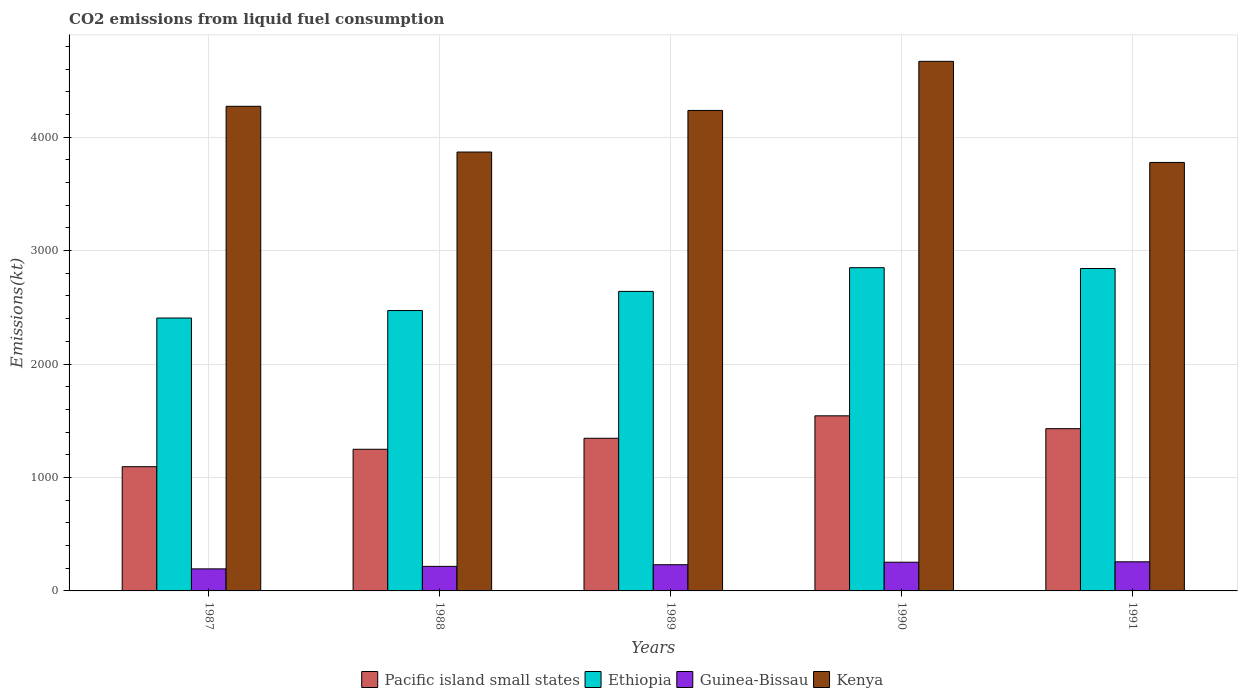How many different coloured bars are there?
Provide a succinct answer. 4. How many groups of bars are there?
Keep it short and to the point. 5. Are the number of bars per tick equal to the number of legend labels?
Make the answer very short. Yes. Are the number of bars on each tick of the X-axis equal?
Keep it short and to the point. Yes. What is the label of the 2nd group of bars from the left?
Keep it short and to the point. 1988. What is the amount of CO2 emitted in Guinea-Bissau in 1989?
Keep it short and to the point. 231.02. Across all years, what is the maximum amount of CO2 emitted in Kenya?
Your answer should be very brief. 4668.09. Across all years, what is the minimum amount of CO2 emitted in Ethiopia?
Give a very brief answer. 2405.55. What is the total amount of CO2 emitted in Kenya in the graph?
Offer a terse response. 2.08e+04. What is the difference between the amount of CO2 emitted in Ethiopia in 1988 and that in 1989?
Make the answer very short. -168.68. What is the difference between the amount of CO2 emitted in Guinea-Bissau in 1988 and the amount of CO2 emitted in Kenya in 1991?
Ensure brevity in your answer.  -3560.66. What is the average amount of CO2 emitted in Pacific island small states per year?
Give a very brief answer. 1332.55. In the year 1989, what is the difference between the amount of CO2 emitted in Ethiopia and amount of CO2 emitted in Guinea-Bissau?
Offer a terse response. 2409.22. In how many years, is the amount of CO2 emitted in Ethiopia greater than 600 kt?
Make the answer very short. 5. What is the ratio of the amount of CO2 emitted in Guinea-Bissau in 1988 to that in 1989?
Your response must be concise. 0.94. What is the difference between the highest and the second highest amount of CO2 emitted in Pacific island small states?
Make the answer very short. 113.32. What is the difference between the highest and the lowest amount of CO2 emitted in Pacific island small states?
Your answer should be compact. 448.51. In how many years, is the amount of CO2 emitted in Ethiopia greater than the average amount of CO2 emitted in Ethiopia taken over all years?
Offer a very short reply. 2. Is the sum of the amount of CO2 emitted in Guinea-Bissau in 1990 and 1991 greater than the maximum amount of CO2 emitted in Kenya across all years?
Give a very brief answer. No. What does the 1st bar from the left in 1989 represents?
Your response must be concise. Pacific island small states. What does the 4th bar from the right in 1990 represents?
Provide a short and direct response. Pacific island small states. Are the values on the major ticks of Y-axis written in scientific E-notation?
Ensure brevity in your answer.  No. Does the graph contain grids?
Keep it short and to the point. Yes. Where does the legend appear in the graph?
Your response must be concise. Bottom center. How many legend labels are there?
Keep it short and to the point. 4. How are the legend labels stacked?
Give a very brief answer. Horizontal. What is the title of the graph?
Keep it short and to the point. CO2 emissions from liquid fuel consumption. What is the label or title of the Y-axis?
Your response must be concise. Emissions(kt). What is the Emissions(kt) in Pacific island small states in 1987?
Your answer should be very brief. 1095. What is the Emissions(kt) of Ethiopia in 1987?
Make the answer very short. 2405.55. What is the Emissions(kt) in Guinea-Bissau in 1987?
Provide a short and direct response. 194.35. What is the Emissions(kt) in Kenya in 1987?
Your answer should be compact. 4272.06. What is the Emissions(kt) in Pacific island small states in 1988?
Provide a succinct answer. 1248.54. What is the Emissions(kt) of Ethiopia in 1988?
Provide a succinct answer. 2471.56. What is the Emissions(kt) of Guinea-Bissau in 1988?
Give a very brief answer. 216.35. What is the Emissions(kt) in Kenya in 1988?
Offer a terse response. 3868.68. What is the Emissions(kt) of Pacific island small states in 1989?
Your response must be concise. 1345.52. What is the Emissions(kt) of Ethiopia in 1989?
Provide a succinct answer. 2640.24. What is the Emissions(kt) of Guinea-Bissau in 1989?
Provide a short and direct response. 231.02. What is the Emissions(kt) of Kenya in 1989?
Provide a short and direct response. 4235.39. What is the Emissions(kt) of Pacific island small states in 1990?
Provide a succinct answer. 1543.51. What is the Emissions(kt) in Ethiopia in 1990?
Ensure brevity in your answer.  2849.26. What is the Emissions(kt) of Guinea-Bissau in 1990?
Give a very brief answer. 253.02. What is the Emissions(kt) in Kenya in 1990?
Ensure brevity in your answer.  4668.09. What is the Emissions(kt) of Pacific island small states in 1991?
Provide a short and direct response. 1430.19. What is the Emissions(kt) in Ethiopia in 1991?
Ensure brevity in your answer.  2841.93. What is the Emissions(kt) in Guinea-Bissau in 1991?
Your answer should be very brief. 256.69. What is the Emissions(kt) in Kenya in 1991?
Provide a short and direct response. 3777.01. Across all years, what is the maximum Emissions(kt) of Pacific island small states?
Offer a very short reply. 1543.51. Across all years, what is the maximum Emissions(kt) in Ethiopia?
Your answer should be very brief. 2849.26. Across all years, what is the maximum Emissions(kt) of Guinea-Bissau?
Provide a short and direct response. 256.69. Across all years, what is the maximum Emissions(kt) in Kenya?
Offer a very short reply. 4668.09. Across all years, what is the minimum Emissions(kt) in Pacific island small states?
Give a very brief answer. 1095. Across all years, what is the minimum Emissions(kt) of Ethiopia?
Make the answer very short. 2405.55. Across all years, what is the minimum Emissions(kt) of Guinea-Bissau?
Your answer should be very brief. 194.35. Across all years, what is the minimum Emissions(kt) of Kenya?
Keep it short and to the point. 3777.01. What is the total Emissions(kt) of Pacific island small states in the graph?
Your answer should be very brief. 6662.76. What is the total Emissions(kt) of Ethiopia in the graph?
Offer a terse response. 1.32e+04. What is the total Emissions(kt) in Guinea-Bissau in the graph?
Provide a succinct answer. 1151.44. What is the total Emissions(kt) of Kenya in the graph?
Your answer should be compact. 2.08e+04. What is the difference between the Emissions(kt) in Pacific island small states in 1987 and that in 1988?
Provide a short and direct response. -153.54. What is the difference between the Emissions(kt) in Ethiopia in 1987 and that in 1988?
Ensure brevity in your answer.  -66.01. What is the difference between the Emissions(kt) in Guinea-Bissau in 1987 and that in 1988?
Provide a succinct answer. -22. What is the difference between the Emissions(kt) of Kenya in 1987 and that in 1988?
Offer a terse response. 403.37. What is the difference between the Emissions(kt) of Pacific island small states in 1987 and that in 1989?
Your response must be concise. -250.52. What is the difference between the Emissions(kt) in Ethiopia in 1987 and that in 1989?
Offer a terse response. -234.69. What is the difference between the Emissions(kt) in Guinea-Bissau in 1987 and that in 1989?
Your answer should be compact. -36.67. What is the difference between the Emissions(kt) of Kenya in 1987 and that in 1989?
Your response must be concise. 36.67. What is the difference between the Emissions(kt) of Pacific island small states in 1987 and that in 1990?
Give a very brief answer. -448.51. What is the difference between the Emissions(kt) in Ethiopia in 1987 and that in 1990?
Your response must be concise. -443.71. What is the difference between the Emissions(kt) of Guinea-Bissau in 1987 and that in 1990?
Keep it short and to the point. -58.67. What is the difference between the Emissions(kt) in Kenya in 1987 and that in 1990?
Your response must be concise. -396.04. What is the difference between the Emissions(kt) of Pacific island small states in 1987 and that in 1991?
Keep it short and to the point. -335.19. What is the difference between the Emissions(kt) in Ethiopia in 1987 and that in 1991?
Your response must be concise. -436.37. What is the difference between the Emissions(kt) of Guinea-Bissau in 1987 and that in 1991?
Keep it short and to the point. -62.34. What is the difference between the Emissions(kt) of Kenya in 1987 and that in 1991?
Keep it short and to the point. 495.05. What is the difference between the Emissions(kt) in Pacific island small states in 1988 and that in 1989?
Make the answer very short. -96.97. What is the difference between the Emissions(kt) in Ethiopia in 1988 and that in 1989?
Your answer should be very brief. -168.68. What is the difference between the Emissions(kt) of Guinea-Bissau in 1988 and that in 1989?
Give a very brief answer. -14.67. What is the difference between the Emissions(kt) of Kenya in 1988 and that in 1989?
Your response must be concise. -366.7. What is the difference between the Emissions(kt) in Pacific island small states in 1988 and that in 1990?
Provide a short and direct response. -294.96. What is the difference between the Emissions(kt) in Ethiopia in 1988 and that in 1990?
Ensure brevity in your answer.  -377.7. What is the difference between the Emissions(kt) of Guinea-Bissau in 1988 and that in 1990?
Keep it short and to the point. -36.67. What is the difference between the Emissions(kt) in Kenya in 1988 and that in 1990?
Make the answer very short. -799.41. What is the difference between the Emissions(kt) in Pacific island small states in 1988 and that in 1991?
Ensure brevity in your answer.  -181.64. What is the difference between the Emissions(kt) of Ethiopia in 1988 and that in 1991?
Provide a short and direct response. -370.37. What is the difference between the Emissions(kt) of Guinea-Bissau in 1988 and that in 1991?
Give a very brief answer. -40.34. What is the difference between the Emissions(kt) of Kenya in 1988 and that in 1991?
Offer a very short reply. 91.67. What is the difference between the Emissions(kt) in Pacific island small states in 1989 and that in 1990?
Offer a terse response. -197.99. What is the difference between the Emissions(kt) of Ethiopia in 1989 and that in 1990?
Keep it short and to the point. -209.02. What is the difference between the Emissions(kt) of Guinea-Bissau in 1989 and that in 1990?
Make the answer very short. -22. What is the difference between the Emissions(kt) of Kenya in 1989 and that in 1990?
Provide a succinct answer. -432.71. What is the difference between the Emissions(kt) of Pacific island small states in 1989 and that in 1991?
Provide a succinct answer. -84.67. What is the difference between the Emissions(kt) in Ethiopia in 1989 and that in 1991?
Offer a terse response. -201.69. What is the difference between the Emissions(kt) of Guinea-Bissau in 1989 and that in 1991?
Give a very brief answer. -25.67. What is the difference between the Emissions(kt) of Kenya in 1989 and that in 1991?
Your answer should be compact. 458.38. What is the difference between the Emissions(kt) of Pacific island small states in 1990 and that in 1991?
Give a very brief answer. 113.32. What is the difference between the Emissions(kt) of Ethiopia in 1990 and that in 1991?
Provide a short and direct response. 7.33. What is the difference between the Emissions(kt) in Guinea-Bissau in 1990 and that in 1991?
Your answer should be very brief. -3.67. What is the difference between the Emissions(kt) of Kenya in 1990 and that in 1991?
Provide a short and direct response. 891.08. What is the difference between the Emissions(kt) of Pacific island small states in 1987 and the Emissions(kt) of Ethiopia in 1988?
Offer a terse response. -1376.56. What is the difference between the Emissions(kt) of Pacific island small states in 1987 and the Emissions(kt) of Guinea-Bissau in 1988?
Your answer should be very brief. 878.65. What is the difference between the Emissions(kt) of Pacific island small states in 1987 and the Emissions(kt) of Kenya in 1988?
Provide a short and direct response. -2773.68. What is the difference between the Emissions(kt) of Ethiopia in 1987 and the Emissions(kt) of Guinea-Bissau in 1988?
Offer a terse response. 2189.2. What is the difference between the Emissions(kt) in Ethiopia in 1987 and the Emissions(kt) in Kenya in 1988?
Your response must be concise. -1463.13. What is the difference between the Emissions(kt) of Guinea-Bissau in 1987 and the Emissions(kt) of Kenya in 1988?
Ensure brevity in your answer.  -3674.33. What is the difference between the Emissions(kt) in Pacific island small states in 1987 and the Emissions(kt) in Ethiopia in 1989?
Provide a succinct answer. -1545.24. What is the difference between the Emissions(kt) in Pacific island small states in 1987 and the Emissions(kt) in Guinea-Bissau in 1989?
Offer a very short reply. 863.98. What is the difference between the Emissions(kt) of Pacific island small states in 1987 and the Emissions(kt) of Kenya in 1989?
Your answer should be compact. -3140.38. What is the difference between the Emissions(kt) of Ethiopia in 1987 and the Emissions(kt) of Guinea-Bissau in 1989?
Your answer should be very brief. 2174.53. What is the difference between the Emissions(kt) in Ethiopia in 1987 and the Emissions(kt) in Kenya in 1989?
Ensure brevity in your answer.  -1829.83. What is the difference between the Emissions(kt) of Guinea-Bissau in 1987 and the Emissions(kt) of Kenya in 1989?
Give a very brief answer. -4041.03. What is the difference between the Emissions(kt) of Pacific island small states in 1987 and the Emissions(kt) of Ethiopia in 1990?
Your response must be concise. -1754.26. What is the difference between the Emissions(kt) of Pacific island small states in 1987 and the Emissions(kt) of Guinea-Bissau in 1990?
Your response must be concise. 841.98. What is the difference between the Emissions(kt) of Pacific island small states in 1987 and the Emissions(kt) of Kenya in 1990?
Give a very brief answer. -3573.09. What is the difference between the Emissions(kt) of Ethiopia in 1987 and the Emissions(kt) of Guinea-Bissau in 1990?
Offer a terse response. 2152.53. What is the difference between the Emissions(kt) of Ethiopia in 1987 and the Emissions(kt) of Kenya in 1990?
Provide a short and direct response. -2262.54. What is the difference between the Emissions(kt) of Guinea-Bissau in 1987 and the Emissions(kt) of Kenya in 1990?
Provide a short and direct response. -4473.74. What is the difference between the Emissions(kt) in Pacific island small states in 1987 and the Emissions(kt) in Ethiopia in 1991?
Give a very brief answer. -1746.92. What is the difference between the Emissions(kt) of Pacific island small states in 1987 and the Emissions(kt) of Guinea-Bissau in 1991?
Make the answer very short. 838.31. What is the difference between the Emissions(kt) of Pacific island small states in 1987 and the Emissions(kt) of Kenya in 1991?
Provide a short and direct response. -2682.01. What is the difference between the Emissions(kt) of Ethiopia in 1987 and the Emissions(kt) of Guinea-Bissau in 1991?
Make the answer very short. 2148.86. What is the difference between the Emissions(kt) of Ethiopia in 1987 and the Emissions(kt) of Kenya in 1991?
Your response must be concise. -1371.46. What is the difference between the Emissions(kt) in Guinea-Bissau in 1987 and the Emissions(kt) in Kenya in 1991?
Your response must be concise. -3582.66. What is the difference between the Emissions(kt) of Pacific island small states in 1988 and the Emissions(kt) of Ethiopia in 1989?
Your answer should be compact. -1391.7. What is the difference between the Emissions(kt) of Pacific island small states in 1988 and the Emissions(kt) of Guinea-Bissau in 1989?
Ensure brevity in your answer.  1017.52. What is the difference between the Emissions(kt) in Pacific island small states in 1988 and the Emissions(kt) in Kenya in 1989?
Give a very brief answer. -2986.84. What is the difference between the Emissions(kt) of Ethiopia in 1988 and the Emissions(kt) of Guinea-Bissau in 1989?
Give a very brief answer. 2240.54. What is the difference between the Emissions(kt) in Ethiopia in 1988 and the Emissions(kt) in Kenya in 1989?
Your answer should be very brief. -1763.83. What is the difference between the Emissions(kt) in Guinea-Bissau in 1988 and the Emissions(kt) in Kenya in 1989?
Keep it short and to the point. -4019.03. What is the difference between the Emissions(kt) in Pacific island small states in 1988 and the Emissions(kt) in Ethiopia in 1990?
Your answer should be very brief. -1600.71. What is the difference between the Emissions(kt) in Pacific island small states in 1988 and the Emissions(kt) in Guinea-Bissau in 1990?
Make the answer very short. 995.52. What is the difference between the Emissions(kt) of Pacific island small states in 1988 and the Emissions(kt) of Kenya in 1990?
Make the answer very short. -3419.55. What is the difference between the Emissions(kt) of Ethiopia in 1988 and the Emissions(kt) of Guinea-Bissau in 1990?
Offer a terse response. 2218.53. What is the difference between the Emissions(kt) of Ethiopia in 1988 and the Emissions(kt) of Kenya in 1990?
Offer a terse response. -2196.53. What is the difference between the Emissions(kt) of Guinea-Bissau in 1988 and the Emissions(kt) of Kenya in 1990?
Your answer should be very brief. -4451.74. What is the difference between the Emissions(kt) of Pacific island small states in 1988 and the Emissions(kt) of Ethiopia in 1991?
Keep it short and to the point. -1593.38. What is the difference between the Emissions(kt) of Pacific island small states in 1988 and the Emissions(kt) of Guinea-Bissau in 1991?
Offer a very short reply. 991.85. What is the difference between the Emissions(kt) of Pacific island small states in 1988 and the Emissions(kt) of Kenya in 1991?
Give a very brief answer. -2528.47. What is the difference between the Emissions(kt) of Ethiopia in 1988 and the Emissions(kt) of Guinea-Bissau in 1991?
Your answer should be compact. 2214.87. What is the difference between the Emissions(kt) of Ethiopia in 1988 and the Emissions(kt) of Kenya in 1991?
Keep it short and to the point. -1305.45. What is the difference between the Emissions(kt) in Guinea-Bissau in 1988 and the Emissions(kt) in Kenya in 1991?
Your response must be concise. -3560.66. What is the difference between the Emissions(kt) in Pacific island small states in 1989 and the Emissions(kt) in Ethiopia in 1990?
Offer a terse response. -1503.74. What is the difference between the Emissions(kt) in Pacific island small states in 1989 and the Emissions(kt) in Guinea-Bissau in 1990?
Offer a terse response. 1092.5. What is the difference between the Emissions(kt) of Pacific island small states in 1989 and the Emissions(kt) of Kenya in 1990?
Offer a very short reply. -3322.57. What is the difference between the Emissions(kt) in Ethiopia in 1989 and the Emissions(kt) in Guinea-Bissau in 1990?
Your answer should be very brief. 2387.22. What is the difference between the Emissions(kt) in Ethiopia in 1989 and the Emissions(kt) in Kenya in 1990?
Provide a succinct answer. -2027.85. What is the difference between the Emissions(kt) in Guinea-Bissau in 1989 and the Emissions(kt) in Kenya in 1990?
Your response must be concise. -4437.07. What is the difference between the Emissions(kt) in Pacific island small states in 1989 and the Emissions(kt) in Ethiopia in 1991?
Make the answer very short. -1496.41. What is the difference between the Emissions(kt) in Pacific island small states in 1989 and the Emissions(kt) in Guinea-Bissau in 1991?
Make the answer very short. 1088.83. What is the difference between the Emissions(kt) of Pacific island small states in 1989 and the Emissions(kt) of Kenya in 1991?
Make the answer very short. -2431.49. What is the difference between the Emissions(kt) of Ethiopia in 1989 and the Emissions(kt) of Guinea-Bissau in 1991?
Keep it short and to the point. 2383.55. What is the difference between the Emissions(kt) in Ethiopia in 1989 and the Emissions(kt) in Kenya in 1991?
Your answer should be very brief. -1136.77. What is the difference between the Emissions(kt) in Guinea-Bissau in 1989 and the Emissions(kt) in Kenya in 1991?
Provide a short and direct response. -3545.99. What is the difference between the Emissions(kt) in Pacific island small states in 1990 and the Emissions(kt) in Ethiopia in 1991?
Keep it short and to the point. -1298.42. What is the difference between the Emissions(kt) of Pacific island small states in 1990 and the Emissions(kt) of Guinea-Bissau in 1991?
Offer a terse response. 1286.82. What is the difference between the Emissions(kt) in Pacific island small states in 1990 and the Emissions(kt) in Kenya in 1991?
Your response must be concise. -2233.5. What is the difference between the Emissions(kt) of Ethiopia in 1990 and the Emissions(kt) of Guinea-Bissau in 1991?
Keep it short and to the point. 2592.57. What is the difference between the Emissions(kt) of Ethiopia in 1990 and the Emissions(kt) of Kenya in 1991?
Your answer should be compact. -927.75. What is the difference between the Emissions(kt) in Guinea-Bissau in 1990 and the Emissions(kt) in Kenya in 1991?
Ensure brevity in your answer.  -3523.99. What is the average Emissions(kt) in Pacific island small states per year?
Your answer should be compact. 1332.55. What is the average Emissions(kt) in Ethiopia per year?
Provide a succinct answer. 2641.71. What is the average Emissions(kt) in Guinea-Bissau per year?
Offer a terse response. 230.29. What is the average Emissions(kt) of Kenya per year?
Offer a very short reply. 4164.25. In the year 1987, what is the difference between the Emissions(kt) of Pacific island small states and Emissions(kt) of Ethiopia?
Your response must be concise. -1310.55. In the year 1987, what is the difference between the Emissions(kt) of Pacific island small states and Emissions(kt) of Guinea-Bissau?
Provide a short and direct response. 900.65. In the year 1987, what is the difference between the Emissions(kt) in Pacific island small states and Emissions(kt) in Kenya?
Your answer should be very brief. -3177.05. In the year 1987, what is the difference between the Emissions(kt) in Ethiopia and Emissions(kt) in Guinea-Bissau?
Provide a succinct answer. 2211.2. In the year 1987, what is the difference between the Emissions(kt) in Ethiopia and Emissions(kt) in Kenya?
Offer a very short reply. -1866.5. In the year 1987, what is the difference between the Emissions(kt) in Guinea-Bissau and Emissions(kt) in Kenya?
Your response must be concise. -4077.7. In the year 1988, what is the difference between the Emissions(kt) in Pacific island small states and Emissions(kt) in Ethiopia?
Provide a succinct answer. -1223.01. In the year 1988, what is the difference between the Emissions(kt) in Pacific island small states and Emissions(kt) in Guinea-Bissau?
Your answer should be compact. 1032.19. In the year 1988, what is the difference between the Emissions(kt) in Pacific island small states and Emissions(kt) in Kenya?
Your response must be concise. -2620.14. In the year 1988, what is the difference between the Emissions(kt) in Ethiopia and Emissions(kt) in Guinea-Bissau?
Your response must be concise. 2255.2. In the year 1988, what is the difference between the Emissions(kt) of Ethiopia and Emissions(kt) of Kenya?
Offer a terse response. -1397.13. In the year 1988, what is the difference between the Emissions(kt) in Guinea-Bissau and Emissions(kt) in Kenya?
Provide a succinct answer. -3652.33. In the year 1989, what is the difference between the Emissions(kt) in Pacific island small states and Emissions(kt) in Ethiopia?
Offer a terse response. -1294.72. In the year 1989, what is the difference between the Emissions(kt) of Pacific island small states and Emissions(kt) of Guinea-Bissau?
Provide a short and direct response. 1114.5. In the year 1989, what is the difference between the Emissions(kt) of Pacific island small states and Emissions(kt) of Kenya?
Your response must be concise. -2889.87. In the year 1989, what is the difference between the Emissions(kt) in Ethiopia and Emissions(kt) in Guinea-Bissau?
Make the answer very short. 2409.22. In the year 1989, what is the difference between the Emissions(kt) in Ethiopia and Emissions(kt) in Kenya?
Give a very brief answer. -1595.14. In the year 1989, what is the difference between the Emissions(kt) in Guinea-Bissau and Emissions(kt) in Kenya?
Keep it short and to the point. -4004.36. In the year 1990, what is the difference between the Emissions(kt) of Pacific island small states and Emissions(kt) of Ethiopia?
Give a very brief answer. -1305.75. In the year 1990, what is the difference between the Emissions(kt) in Pacific island small states and Emissions(kt) in Guinea-Bissau?
Offer a terse response. 1290.49. In the year 1990, what is the difference between the Emissions(kt) in Pacific island small states and Emissions(kt) in Kenya?
Your answer should be compact. -3124.58. In the year 1990, what is the difference between the Emissions(kt) of Ethiopia and Emissions(kt) of Guinea-Bissau?
Your answer should be compact. 2596.24. In the year 1990, what is the difference between the Emissions(kt) of Ethiopia and Emissions(kt) of Kenya?
Offer a terse response. -1818.83. In the year 1990, what is the difference between the Emissions(kt) in Guinea-Bissau and Emissions(kt) in Kenya?
Give a very brief answer. -4415.07. In the year 1991, what is the difference between the Emissions(kt) in Pacific island small states and Emissions(kt) in Ethiopia?
Give a very brief answer. -1411.74. In the year 1991, what is the difference between the Emissions(kt) of Pacific island small states and Emissions(kt) of Guinea-Bissau?
Keep it short and to the point. 1173.5. In the year 1991, what is the difference between the Emissions(kt) of Pacific island small states and Emissions(kt) of Kenya?
Give a very brief answer. -2346.82. In the year 1991, what is the difference between the Emissions(kt) in Ethiopia and Emissions(kt) in Guinea-Bissau?
Your answer should be compact. 2585.24. In the year 1991, what is the difference between the Emissions(kt) in Ethiopia and Emissions(kt) in Kenya?
Offer a terse response. -935.09. In the year 1991, what is the difference between the Emissions(kt) of Guinea-Bissau and Emissions(kt) of Kenya?
Your response must be concise. -3520.32. What is the ratio of the Emissions(kt) in Pacific island small states in 1987 to that in 1988?
Offer a terse response. 0.88. What is the ratio of the Emissions(kt) of Ethiopia in 1987 to that in 1988?
Offer a very short reply. 0.97. What is the ratio of the Emissions(kt) of Guinea-Bissau in 1987 to that in 1988?
Offer a very short reply. 0.9. What is the ratio of the Emissions(kt) in Kenya in 1987 to that in 1988?
Provide a succinct answer. 1.1. What is the ratio of the Emissions(kt) of Pacific island small states in 1987 to that in 1989?
Offer a terse response. 0.81. What is the ratio of the Emissions(kt) in Ethiopia in 1987 to that in 1989?
Make the answer very short. 0.91. What is the ratio of the Emissions(kt) in Guinea-Bissau in 1987 to that in 1989?
Your answer should be compact. 0.84. What is the ratio of the Emissions(kt) of Kenya in 1987 to that in 1989?
Your answer should be very brief. 1.01. What is the ratio of the Emissions(kt) of Pacific island small states in 1987 to that in 1990?
Keep it short and to the point. 0.71. What is the ratio of the Emissions(kt) in Ethiopia in 1987 to that in 1990?
Provide a short and direct response. 0.84. What is the ratio of the Emissions(kt) of Guinea-Bissau in 1987 to that in 1990?
Provide a succinct answer. 0.77. What is the ratio of the Emissions(kt) of Kenya in 1987 to that in 1990?
Offer a terse response. 0.92. What is the ratio of the Emissions(kt) in Pacific island small states in 1987 to that in 1991?
Provide a short and direct response. 0.77. What is the ratio of the Emissions(kt) in Ethiopia in 1987 to that in 1991?
Make the answer very short. 0.85. What is the ratio of the Emissions(kt) in Guinea-Bissau in 1987 to that in 1991?
Ensure brevity in your answer.  0.76. What is the ratio of the Emissions(kt) of Kenya in 1987 to that in 1991?
Keep it short and to the point. 1.13. What is the ratio of the Emissions(kt) of Pacific island small states in 1988 to that in 1989?
Your answer should be very brief. 0.93. What is the ratio of the Emissions(kt) of Ethiopia in 1988 to that in 1989?
Ensure brevity in your answer.  0.94. What is the ratio of the Emissions(kt) in Guinea-Bissau in 1988 to that in 1989?
Provide a short and direct response. 0.94. What is the ratio of the Emissions(kt) in Kenya in 1988 to that in 1989?
Keep it short and to the point. 0.91. What is the ratio of the Emissions(kt) in Pacific island small states in 1988 to that in 1990?
Offer a very short reply. 0.81. What is the ratio of the Emissions(kt) of Ethiopia in 1988 to that in 1990?
Offer a terse response. 0.87. What is the ratio of the Emissions(kt) in Guinea-Bissau in 1988 to that in 1990?
Give a very brief answer. 0.86. What is the ratio of the Emissions(kt) of Kenya in 1988 to that in 1990?
Offer a terse response. 0.83. What is the ratio of the Emissions(kt) in Pacific island small states in 1988 to that in 1991?
Ensure brevity in your answer.  0.87. What is the ratio of the Emissions(kt) in Ethiopia in 1988 to that in 1991?
Give a very brief answer. 0.87. What is the ratio of the Emissions(kt) in Guinea-Bissau in 1988 to that in 1991?
Keep it short and to the point. 0.84. What is the ratio of the Emissions(kt) in Kenya in 1988 to that in 1991?
Provide a succinct answer. 1.02. What is the ratio of the Emissions(kt) of Pacific island small states in 1989 to that in 1990?
Your answer should be very brief. 0.87. What is the ratio of the Emissions(kt) of Ethiopia in 1989 to that in 1990?
Provide a succinct answer. 0.93. What is the ratio of the Emissions(kt) in Guinea-Bissau in 1989 to that in 1990?
Give a very brief answer. 0.91. What is the ratio of the Emissions(kt) in Kenya in 1989 to that in 1990?
Make the answer very short. 0.91. What is the ratio of the Emissions(kt) of Pacific island small states in 1989 to that in 1991?
Provide a short and direct response. 0.94. What is the ratio of the Emissions(kt) of Ethiopia in 1989 to that in 1991?
Provide a succinct answer. 0.93. What is the ratio of the Emissions(kt) of Guinea-Bissau in 1989 to that in 1991?
Your answer should be compact. 0.9. What is the ratio of the Emissions(kt) of Kenya in 1989 to that in 1991?
Provide a short and direct response. 1.12. What is the ratio of the Emissions(kt) in Pacific island small states in 1990 to that in 1991?
Your answer should be very brief. 1.08. What is the ratio of the Emissions(kt) of Guinea-Bissau in 1990 to that in 1991?
Ensure brevity in your answer.  0.99. What is the ratio of the Emissions(kt) in Kenya in 1990 to that in 1991?
Give a very brief answer. 1.24. What is the difference between the highest and the second highest Emissions(kt) in Pacific island small states?
Offer a terse response. 113.32. What is the difference between the highest and the second highest Emissions(kt) of Ethiopia?
Make the answer very short. 7.33. What is the difference between the highest and the second highest Emissions(kt) in Guinea-Bissau?
Provide a succinct answer. 3.67. What is the difference between the highest and the second highest Emissions(kt) of Kenya?
Provide a short and direct response. 396.04. What is the difference between the highest and the lowest Emissions(kt) of Pacific island small states?
Make the answer very short. 448.51. What is the difference between the highest and the lowest Emissions(kt) of Ethiopia?
Your response must be concise. 443.71. What is the difference between the highest and the lowest Emissions(kt) of Guinea-Bissau?
Offer a terse response. 62.34. What is the difference between the highest and the lowest Emissions(kt) of Kenya?
Provide a short and direct response. 891.08. 